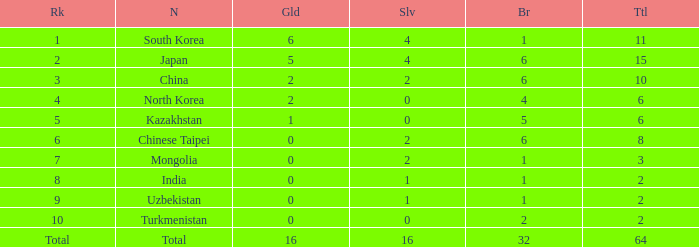How many Golds did Rank 10 get, with a Bronze larger than 2? 0.0. 